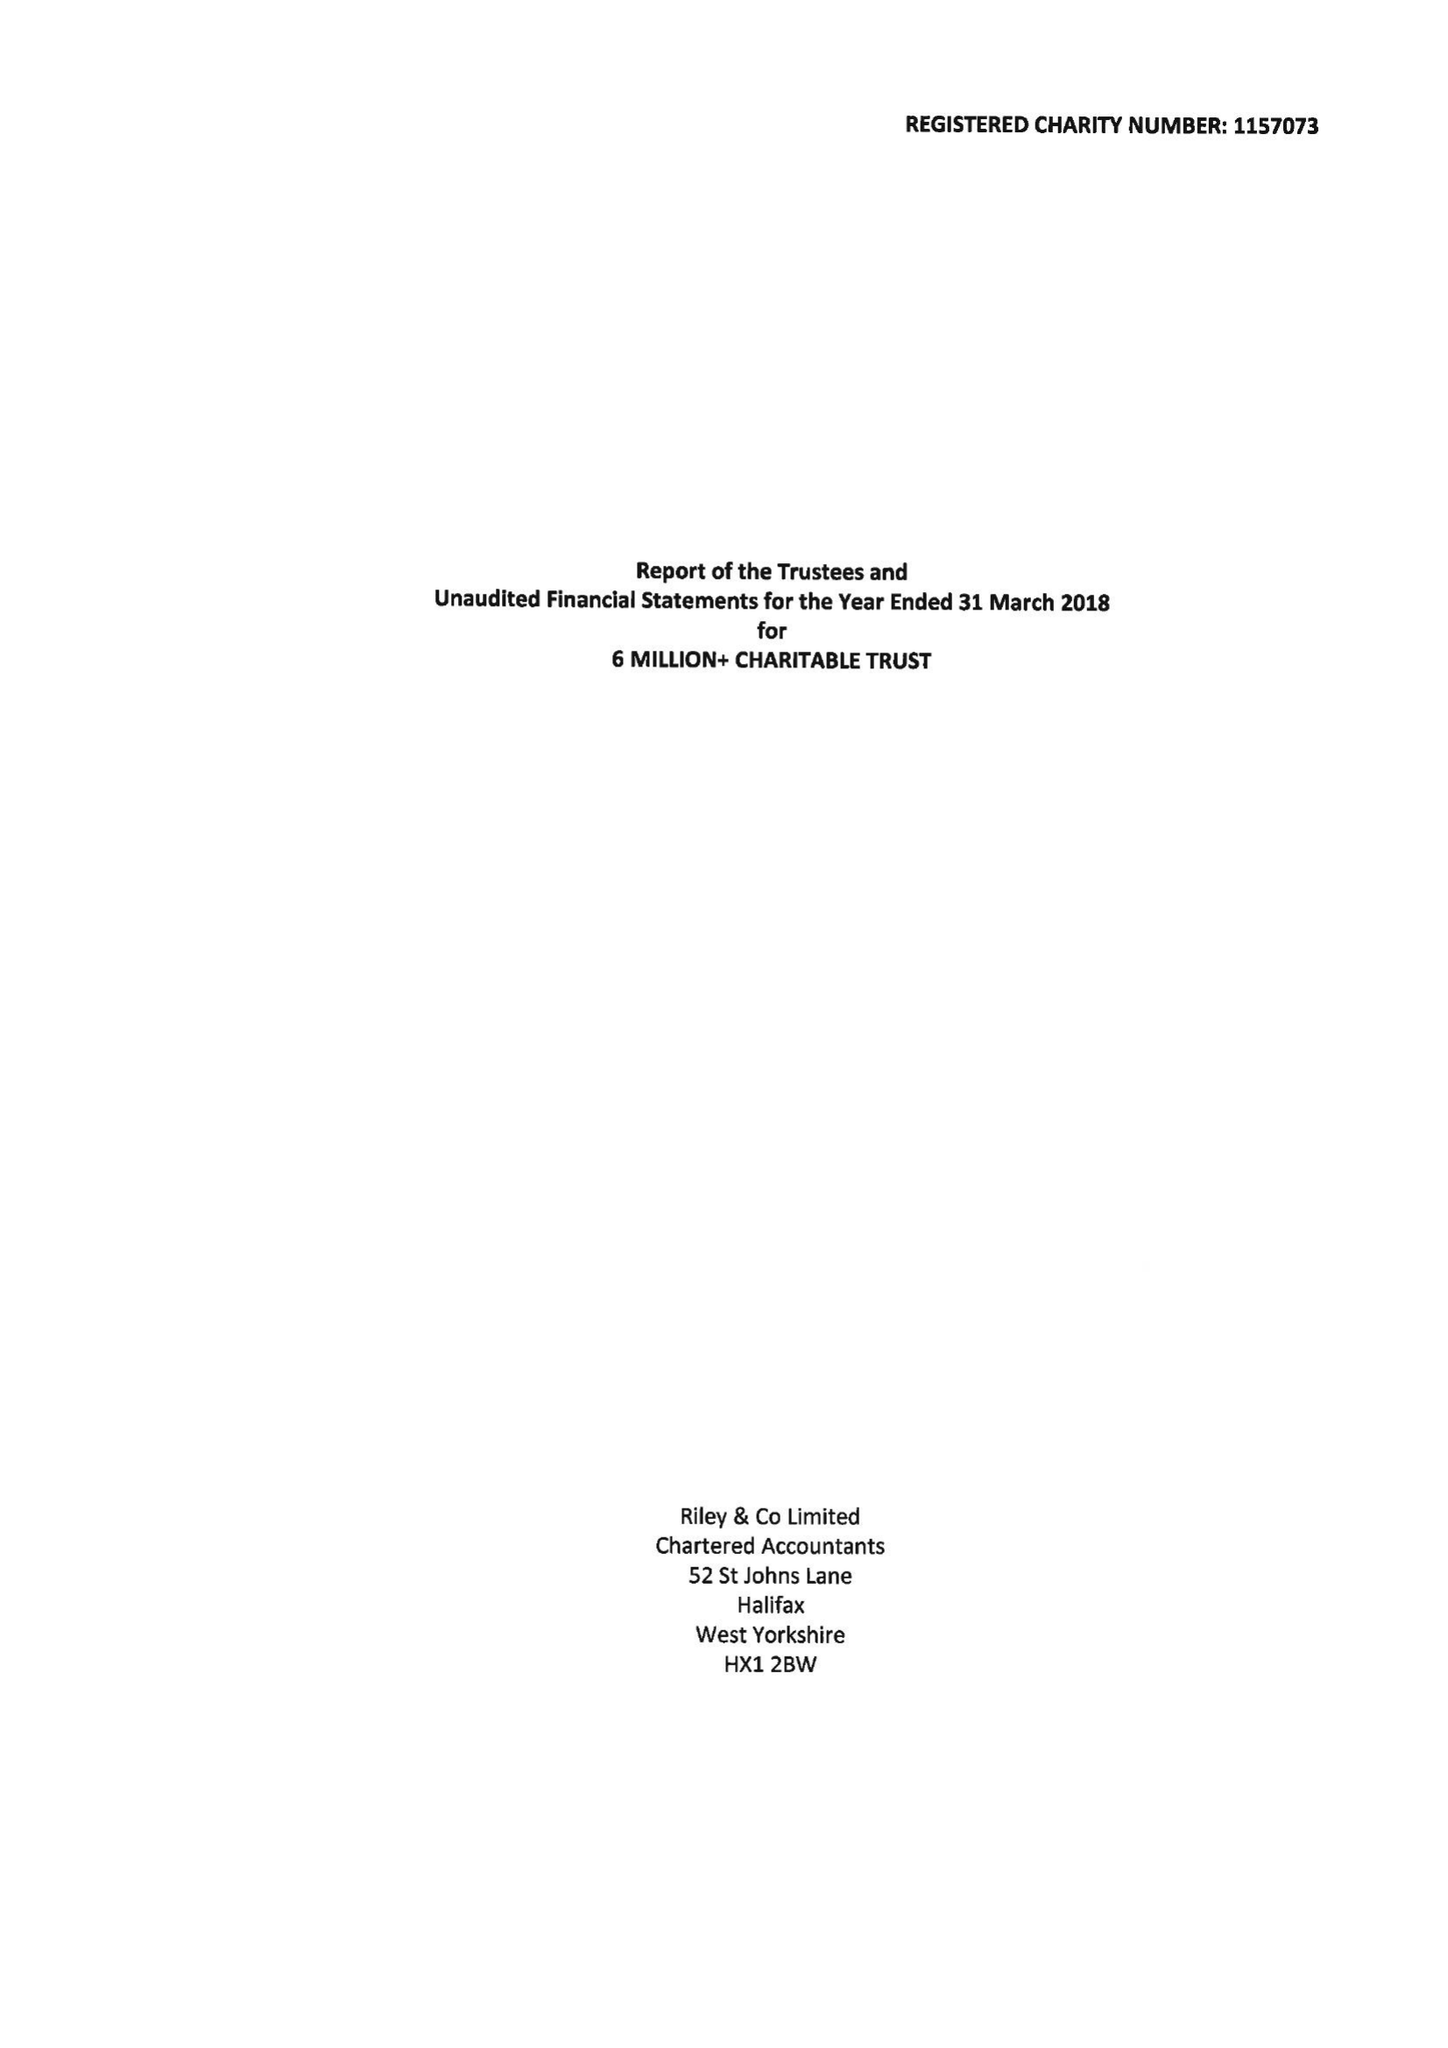What is the value for the address__postcode?
Answer the question using a single word or phrase. HD1 4TX 